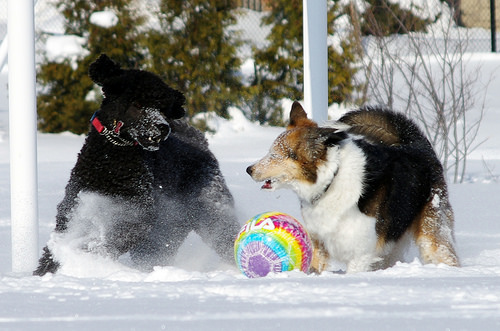<image>
Is the beachball on the snow? Yes. Looking at the image, I can see the beachball is positioned on top of the snow, with the snow providing support. 